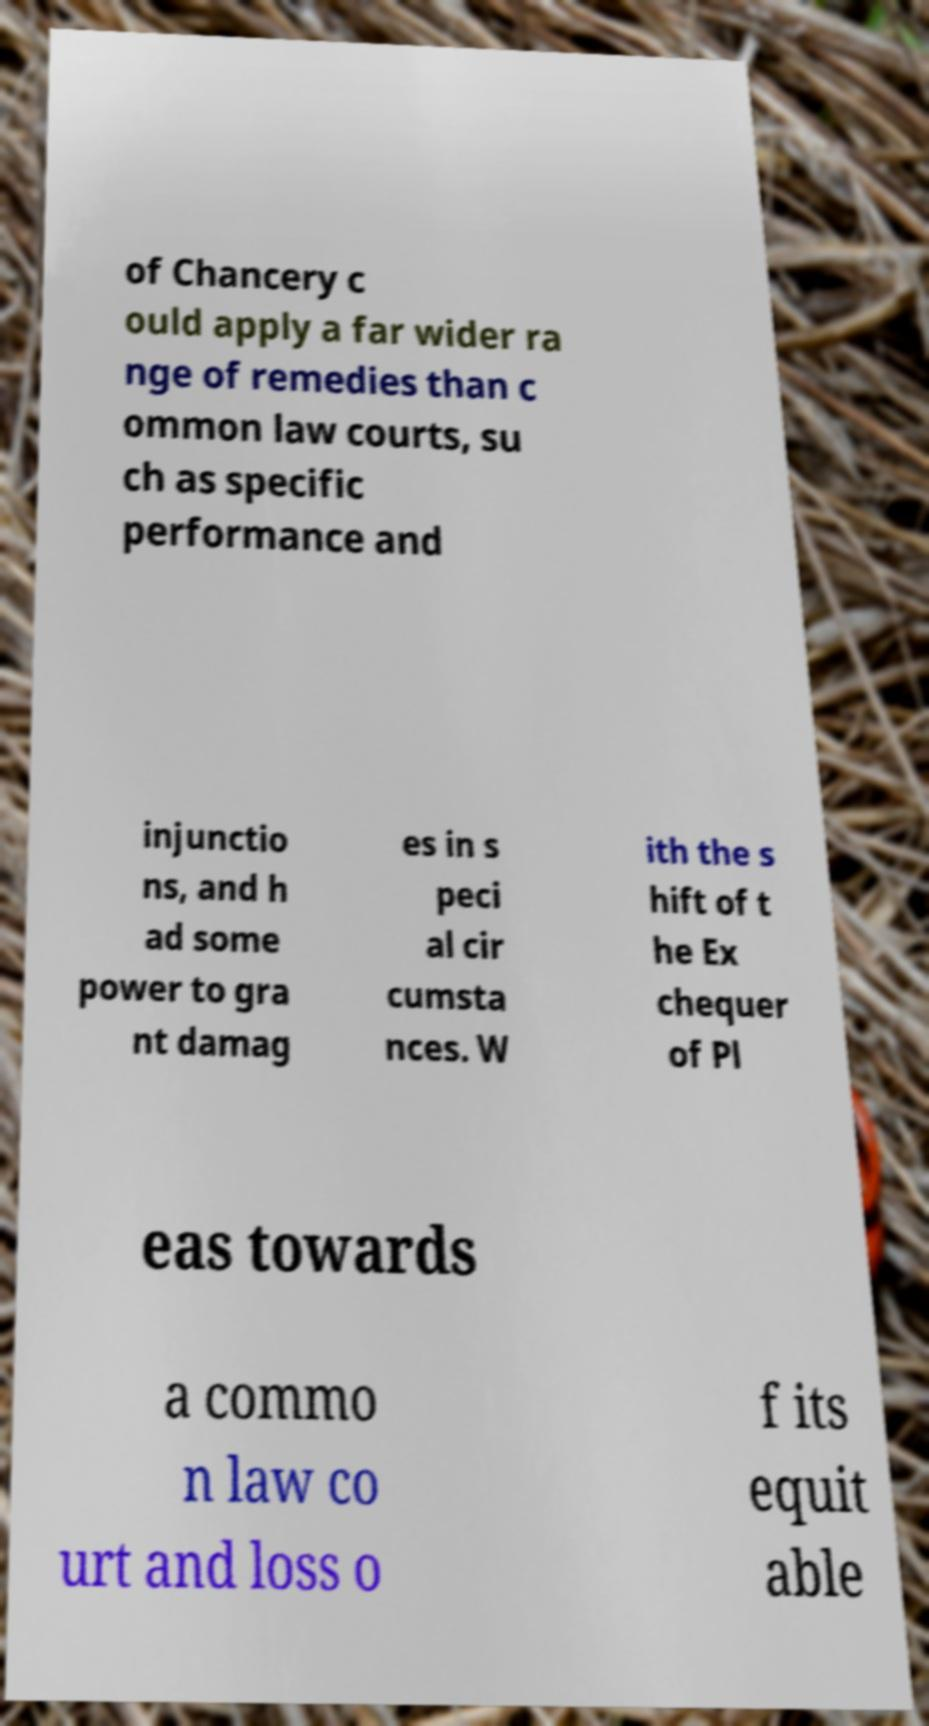Could you extract and type out the text from this image? of Chancery c ould apply a far wider ra nge of remedies than c ommon law courts, su ch as specific performance and injunctio ns, and h ad some power to gra nt damag es in s peci al cir cumsta nces. W ith the s hift of t he Ex chequer of Pl eas towards a commo n law co urt and loss o f its equit able 